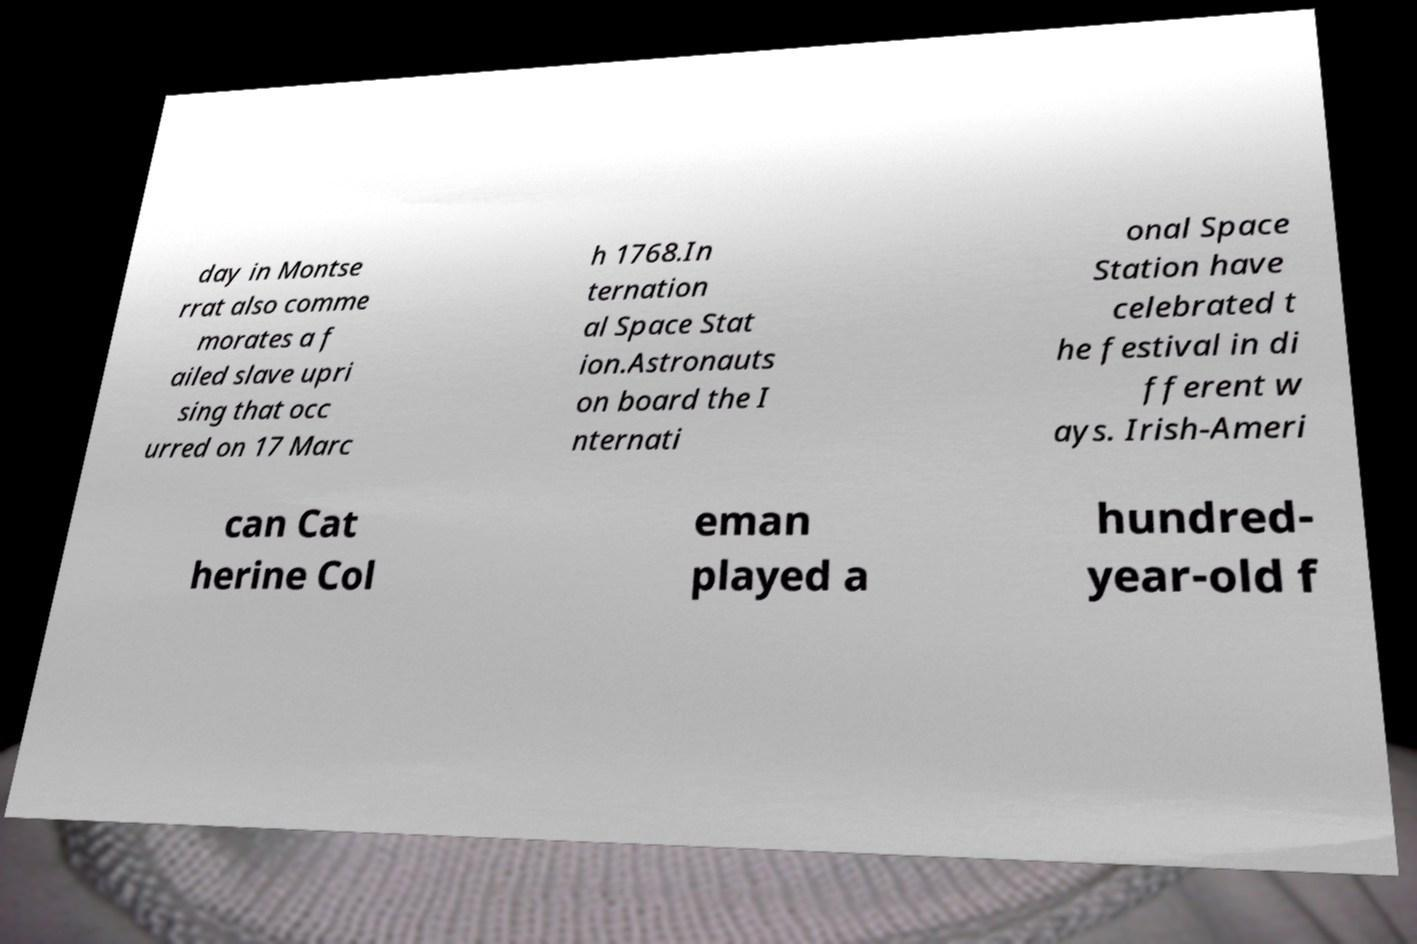Can you accurately transcribe the text from the provided image for me? day in Montse rrat also comme morates a f ailed slave upri sing that occ urred on 17 Marc h 1768.In ternation al Space Stat ion.Astronauts on board the I nternati onal Space Station have celebrated t he festival in di fferent w ays. Irish-Ameri can Cat herine Col eman played a hundred- year-old f 